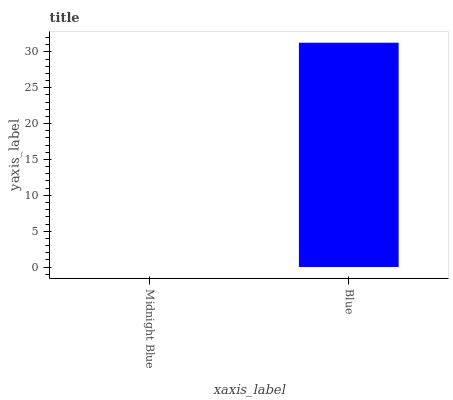Is Midnight Blue the minimum?
Answer yes or no. Yes. Is Blue the maximum?
Answer yes or no. Yes. Is Blue the minimum?
Answer yes or no. No. Is Blue greater than Midnight Blue?
Answer yes or no. Yes. Is Midnight Blue less than Blue?
Answer yes or no. Yes. Is Midnight Blue greater than Blue?
Answer yes or no. No. Is Blue less than Midnight Blue?
Answer yes or no. No. Is Blue the high median?
Answer yes or no. Yes. Is Midnight Blue the low median?
Answer yes or no. Yes. Is Midnight Blue the high median?
Answer yes or no. No. Is Blue the low median?
Answer yes or no. No. 